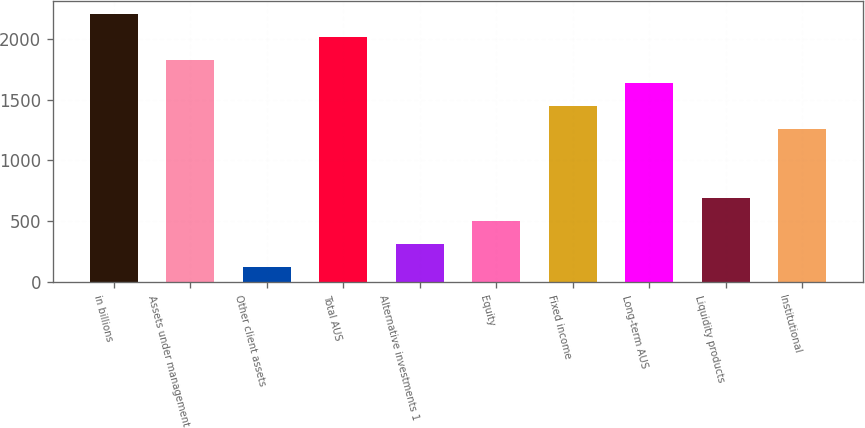Convert chart to OTSL. <chart><loc_0><loc_0><loc_500><loc_500><bar_chart><fcel>in billions<fcel>Assets under management<fcel>Other client assets<fcel>Total AUS<fcel>Alternative investments 1<fcel>Equity<fcel>Fixed income<fcel>Long-term AUS<fcel>Liquidity products<fcel>Institutional<nl><fcel>2202<fcel>1824<fcel>123<fcel>2013<fcel>312<fcel>501<fcel>1446<fcel>1635<fcel>690<fcel>1257<nl></chart> 